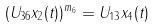<formula> <loc_0><loc_0><loc_500><loc_500>( U _ { 3 6 } x _ { 2 } ( t ) ) ^ { m _ { 6 } } = U _ { 1 3 } x _ { 4 } ( t )</formula> 